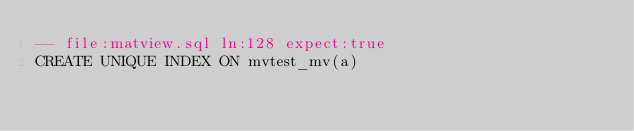<code> <loc_0><loc_0><loc_500><loc_500><_SQL_>-- file:matview.sql ln:128 expect:true
CREATE UNIQUE INDEX ON mvtest_mv(a)
</code> 